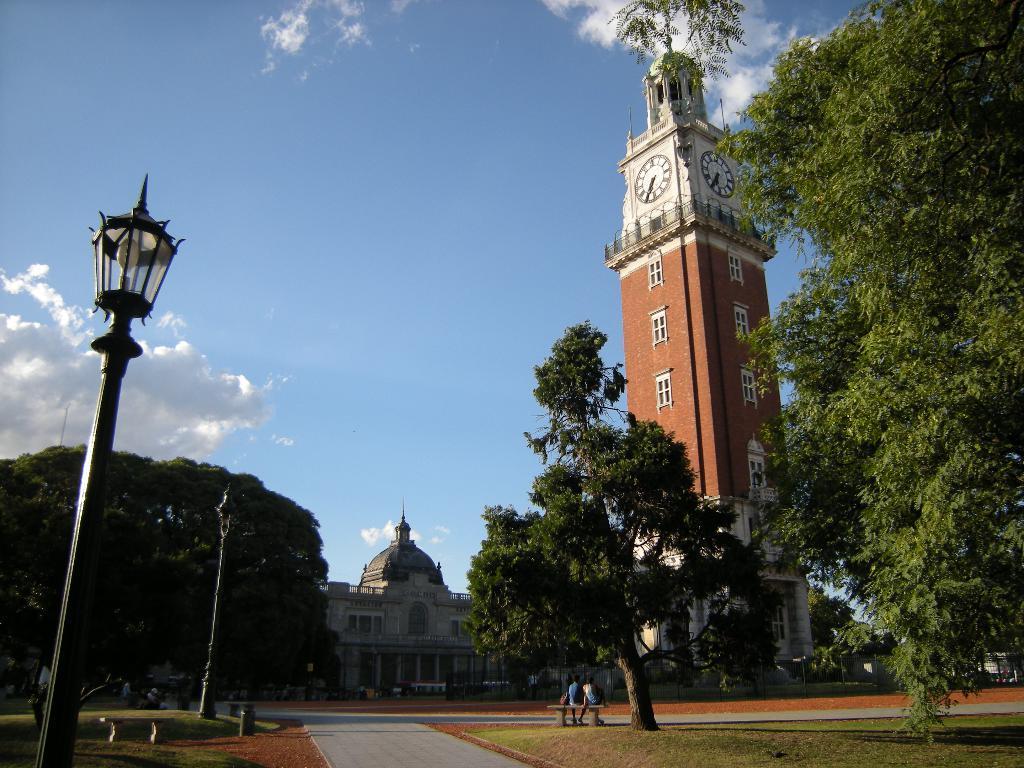How would you summarize this image in a sentence or two? In this image we can see a building and a clock tower. We can also see some street poles, benches, a container on the ground, the pathway, some grass, two people sitting on a bench, a group of trees and the sky which looks cloudy. 